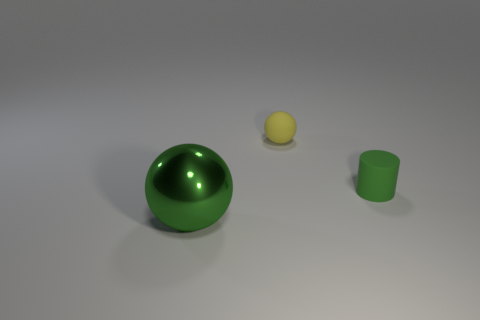What is the material of the yellow sphere that is the same size as the green rubber cylinder?
Your response must be concise. Rubber. What is the color of the matte cylinder?
Ensure brevity in your answer.  Green. What material is the object that is both on the right side of the big metallic sphere and in front of the small yellow ball?
Your answer should be very brief. Rubber. Is there a large green metal sphere to the right of the ball that is behind the rubber thing in front of the small yellow rubber ball?
Keep it short and to the point. No. What is the size of the cylinder that is the same color as the metallic thing?
Give a very brief answer. Small. There is a tiny green cylinder; are there any small matte balls in front of it?
Make the answer very short. No. What number of other things are there of the same shape as the tiny yellow thing?
Keep it short and to the point. 1. There is a matte sphere that is the same size as the green rubber cylinder; what color is it?
Keep it short and to the point. Yellow. Are there fewer green objects that are behind the small cylinder than yellow rubber objects that are to the left of the big green ball?
Provide a short and direct response. No. How many yellow spheres are behind the thing that is on the right side of the tiny object on the left side of the tiny green thing?
Offer a terse response. 1. 